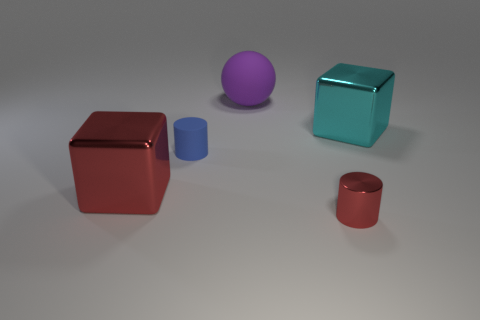Subtract all brown cylinders. Subtract all blue blocks. How many cylinders are left? 2 Add 2 tiny cylinders. How many objects exist? 7 Subtract all cylinders. How many objects are left? 3 Add 5 big purple balls. How many big purple balls are left? 6 Add 3 shiny cylinders. How many shiny cylinders exist? 4 Subtract 0 green cubes. How many objects are left? 5 Subtract all tiny blue objects. Subtract all large red blocks. How many objects are left? 3 